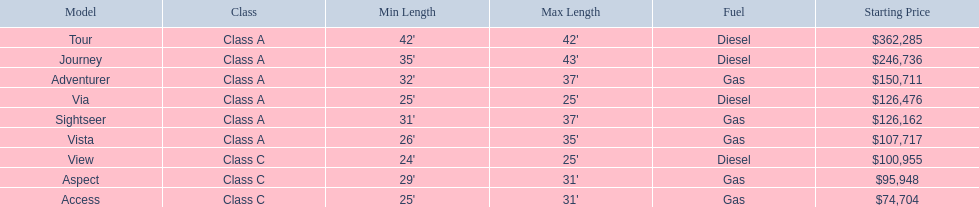Which of the models in the table use diesel fuel? Tour, Journey, Via, View. Of these models, which are class a? Tour, Journey, Via. Which of them are greater than 35' in length? Tour, Journey. Which of the two models is more expensive? Tour. 